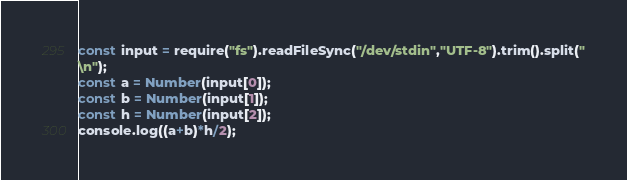<code> <loc_0><loc_0><loc_500><loc_500><_JavaScript_>const input = require("fs").readFileSync("/dev/stdin","UTF-8").trim().split("
\n");
const a = Number(input[0]);
const b = Number(input[1]);
const h = Number(input[2]);
console.log((a+b)*h/2);
</code> 